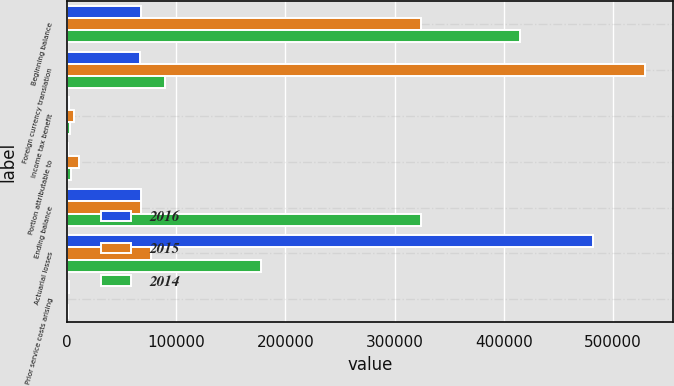Convert chart. <chart><loc_0><loc_0><loc_500><loc_500><stacked_bar_chart><ecel><fcel>Beginning balance<fcel>Foreign currency translation<fcel>Income tax benefit<fcel>Portion attributable to<fcel>Ending balance<fcel>Actuarial losses<fcel>Prior service costs arising<nl><fcel>2016<fcel>67884<fcel>66459<fcel>2120<fcel>695<fcel>67884<fcel>481331<fcel>1561<nl><fcel>2015<fcel>324596<fcel>528908<fcel>6520<fcel>10699<fcel>67884<fcel>77228<fcel>79<nl><fcel>2014<fcel>414401<fcel>89805<fcel>2236<fcel>3601<fcel>324596<fcel>177243<fcel>468<nl></chart> 